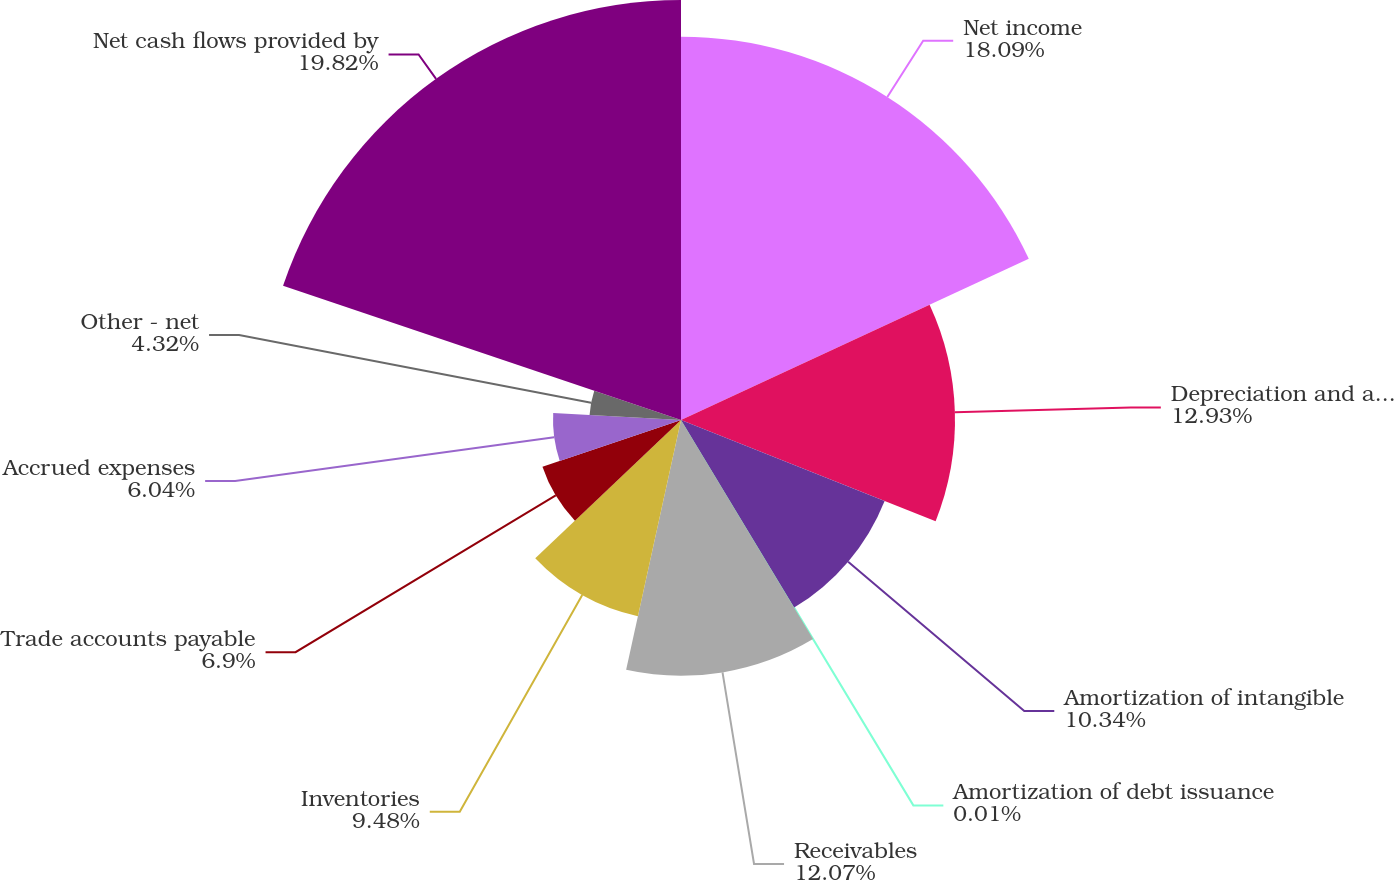Convert chart to OTSL. <chart><loc_0><loc_0><loc_500><loc_500><pie_chart><fcel>Net income<fcel>Depreciation and amortization<fcel>Amortization of intangible<fcel>Amortization of debt issuance<fcel>Receivables<fcel>Inventories<fcel>Trade accounts payable<fcel>Accrued expenses<fcel>Other - net<fcel>Net cash flows provided by<nl><fcel>18.09%<fcel>12.93%<fcel>10.34%<fcel>0.01%<fcel>12.07%<fcel>9.48%<fcel>6.9%<fcel>6.04%<fcel>4.32%<fcel>19.82%<nl></chart> 